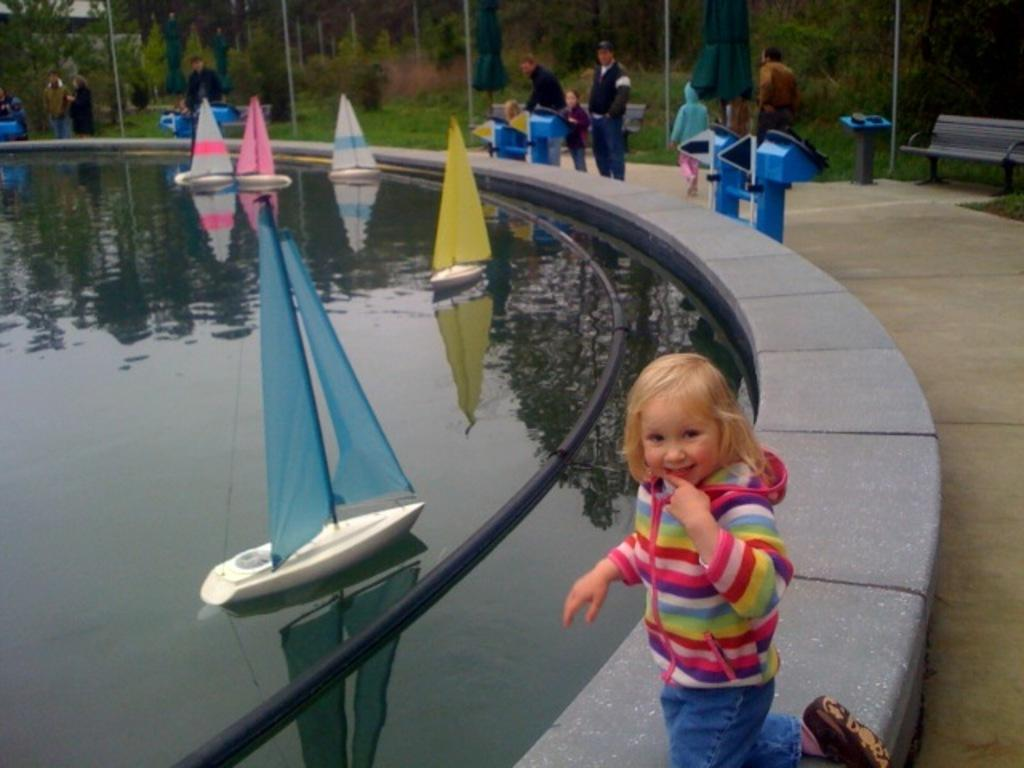What is on the water surface in the image? There are boats on the water surface in the image. Can you describe the people visible in the image? There are people visible in the image. What type of vegetation is present in the image? Trees are present in the image. What type of seating is available in the image? There is a bench in the image. What are the poles used for in the image? The poles are visible in the image, but their purpose is not specified. What are the umbrellas used for in the image? The umbrellas are present in the image, likely for providing shade. What colors are the objects in the image? There are objects in blue and black color in the image. What type of team is playing a game on the water in the image? There is no team playing a game on the water in the image; it features boats on the water surface. What type of rod is being used to catch fish in the image? There is no rod or fishing activity depicted in the image. What type of bomb is being defused in the image? There is no bomb or defusing activity depicted in the image. 